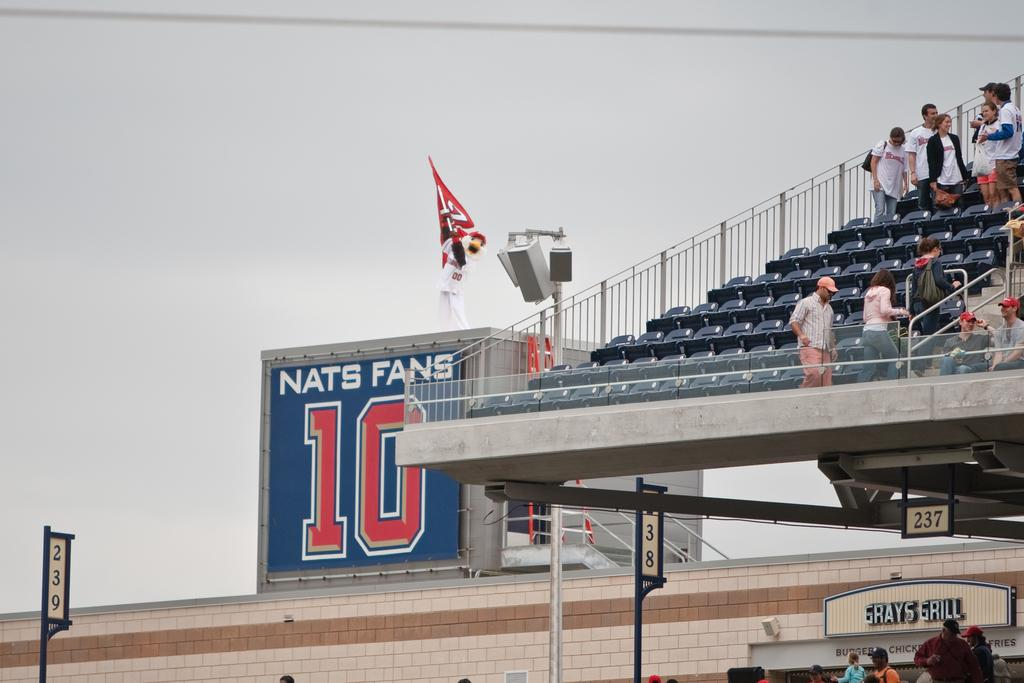What can be seen in the foreground of the image? In the foreground of the image, there are poles, a fence, a shed, and a group of people. What type of location might the image be taken in? The image appears to be taken in a stadium. What is visible in the background of the image? The sky is visible in the background of the image. How many buttons are on the parcel being held by the person in the image? There is no parcel or person holding a parcel visible in the image. What type of account is being discussed by the group of people in the image? There is no discussion or mention of an account in the image; the group of people is not engaged in any activity that would involve an account. 